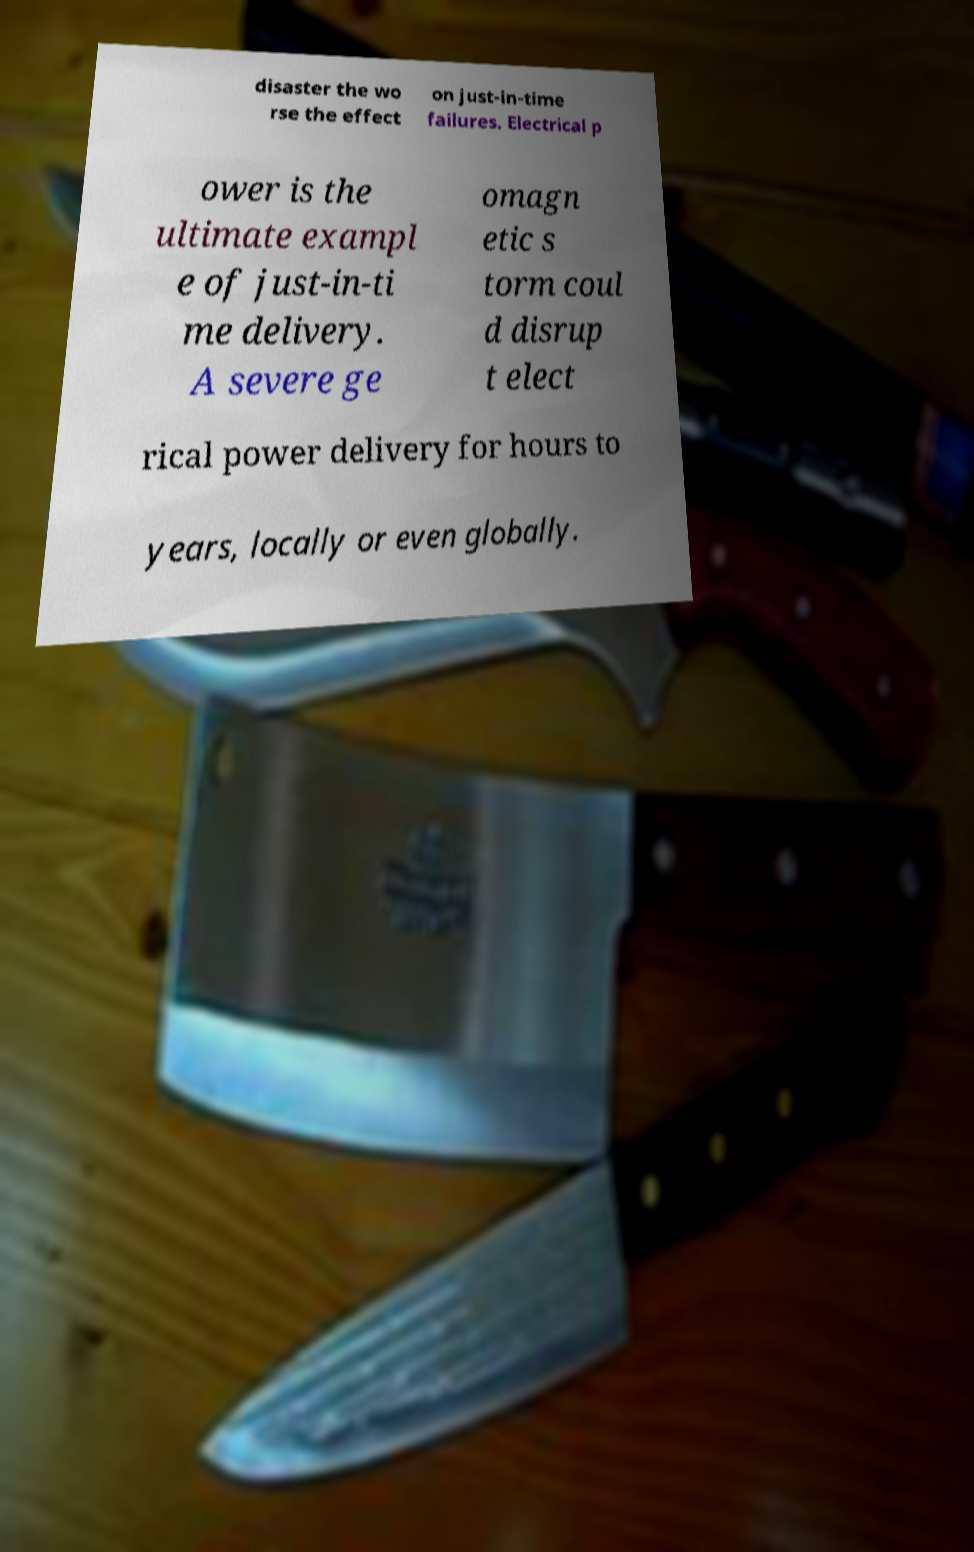Please identify and transcribe the text found in this image. disaster the wo rse the effect on just-in-time failures. Electrical p ower is the ultimate exampl e of just-in-ti me delivery. A severe ge omagn etic s torm coul d disrup t elect rical power delivery for hours to years, locally or even globally. 